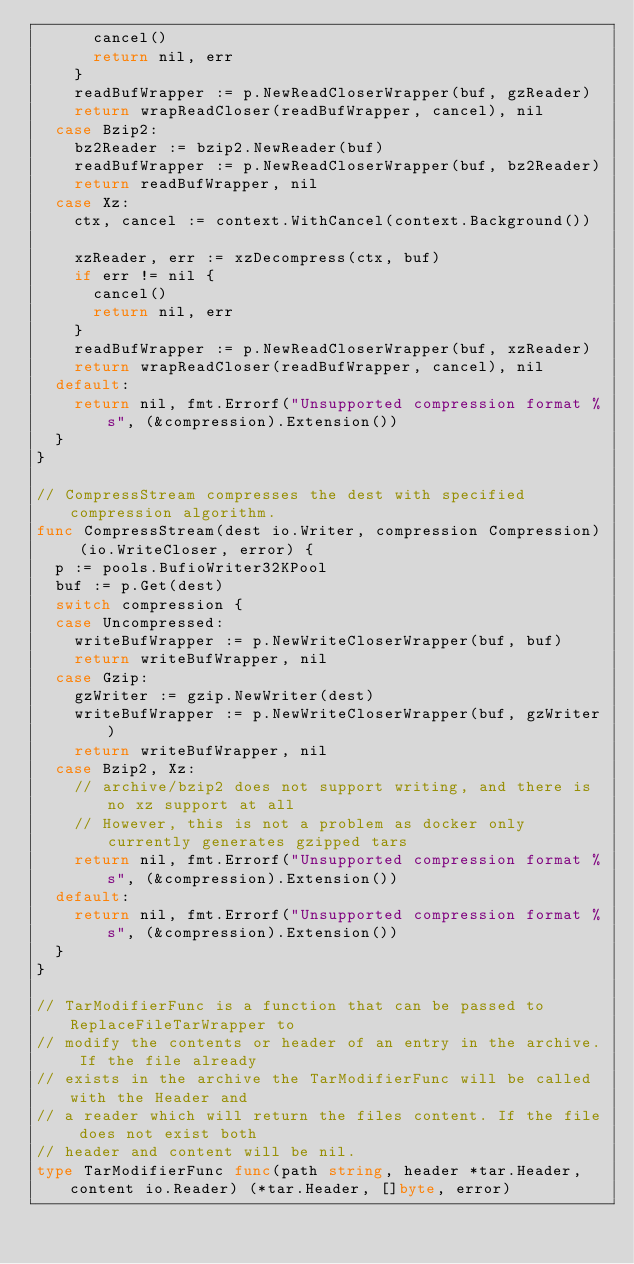Convert code to text. <code><loc_0><loc_0><loc_500><loc_500><_Go_>			cancel()
			return nil, err
		}
		readBufWrapper := p.NewReadCloserWrapper(buf, gzReader)
		return wrapReadCloser(readBufWrapper, cancel), nil
	case Bzip2:
		bz2Reader := bzip2.NewReader(buf)
		readBufWrapper := p.NewReadCloserWrapper(buf, bz2Reader)
		return readBufWrapper, nil
	case Xz:
		ctx, cancel := context.WithCancel(context.Background())

		xzReader, err := xzDecompress(ctx, buf)
		if err != nil {
			cancel()
			return nil, err
		}
		readBufWrapper := p.NewReadCloserWrapper(buf, xzReader)
		return wrapReadCloser(readBufWrapper, cancel), nil
	default:
		return nil, fmt.Errorf("Unsupported compression format %s", (&compression).Extension())
	}
}

// CompressStream compresses the dest with specified compression algorithm.
func CompressStream(dest io.Writer, compression Compression) (io.WriteCloser, error) {
	p := pools.BufioWriter32KPool
	buf := p.Get(dest)
	switch compression {
	case Uncompressed:
		writeBufWrapper := p.NewWriteCloserWrapper(buf, buf)
		return writeBufWrapper, nil
	case Gzip:
		gzWriter := gzip.NewWriter(dest)
		writeBufWrapper := p.NewWriteCloserWrapper(buf, gzWriter)
		return writeBufWrapper, nil
	case Bzip2, Xz:
		// archive/bzip2 does not support writing, and there is no xz support at all
		// However, this is not a problem as docker only currently generates gzipped tars
		return nil, fmt.Errorf("Unsupported compression format %s", (&compression).Extension())
	default:
		return nil, fmt.Errorf("Unsupported compression format %s", (&compression).Extension())
	}
}

// TarModifierFunc is a function that can be passed to ReplaceFileTarWrapper to
// modify the contents or header of an entry in the archive. If the file already
// exists in the archive the TarModifierFunc will be called with the Header and
// a reader which will return the files content. If the file does not exist both
// header and content will be nil.
type TarModifierFunc func(path string, header *tar.Header, content io.Reader) (*tar.Header, []byte, error)
</code> 